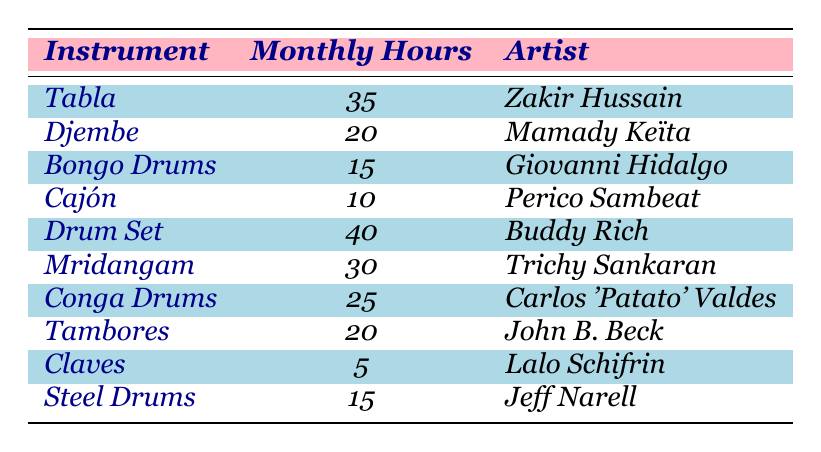What is the instrument with the highest monthly practice hours? By examining the "Monthly Hours" column, I see that the "Drum Set" has the highest value at 40 hours.
Answer: Drum Set Which artist practices the Tabla? The "Artist" column shows that Zakir Hussain is associated with the Tabla.
Answer: Zakir Hussain What is the total number of monthly practice hours for Cajón and Steel Drums combined? Adding the monthly hours for Cajón (10) and Steel Drums (15) gives 10 + 15 = 25 hours.
Answer: 25 How many percussion instruments have monthly practice hours greater than 20? The instruments with more than 20 hours are Tabla (35), Drum Set (40), Mridangam (30), and Conga Drums (25), totaling 4 instruments.
Answer: 4 Is there an instrument on the list that has 5 monthly practice hours? Looking at the "Monthly Hours" column, I find that Claves has exactly 5 monthly hours.
Answer: Yes What is the average monthly practice hours across all instruments? Calculating the total monthly hours is: 35 + 20 + 15 + 10 + 40 + 30 + 25 + 20 + 5 + 15 = 210. There are 10 instruments, so the average is 210 / 10 = 21 hours.
Answer: 21 What is the difference between the monthly practice hours of Djembe and Mridangam? The monthly hours for Djembe is 20 and for Mridangam is 30. The difference is 30 - 20 = 10 hours.
Answer: 10 Are there any instruments listed that require less than 15 monthly practice hours? The instruments with less than 15 hours are Bongo Drums (15) and Cajón (10), along with Claves (5), so yes, there are instruments with less than 15 hours.
Answer: Yes Which instrument has the lowest monthly practice hours? By reviewing the table, I see that Claves has the lowest monthly practice hours at 5.
Answer: Claves How many more hours does the Drum Set practice compared to the Claves? The Drum Set practices for 40 hours and Claves for 5 hours. Thus, 40 - 5 = 35 hours more.
Answer: 35 